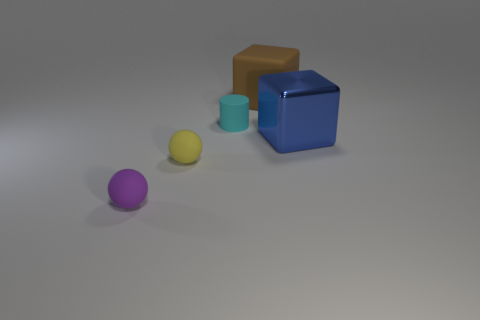How many tiny objects are purple things or purple shiny balls?
Your response must be concise. 1. There is a thing on the right side of the large object that is behind the block that is in front of the big rubber block; how big is it?
Your answer should be compact. Large. How many cylinders have the same size as the metallic cube?
Keep it short and to the point. 0. What number of things are either large red objects or blocks in front of the large brown matte block?
Offer a very short reply. 1. The small yellow matte thing is what shape?
Offer a terse response. Sphere. Is the color of the matte cube the same as the big shiny block?
Make the answer very short. No. Are there an equal number of cyan matte things and big green shiny cylinders?
Provide a short and direct response. No. There is a matte cube that is the same size as the metal object; what is its color?
Provide a short and direct response. Brown. How many cyan things are either rubber blocks or matte spheres?
Give a very brief answer. 0. Are there more small rubber blocks than rubber things?
Keep it short and to the point. No. 